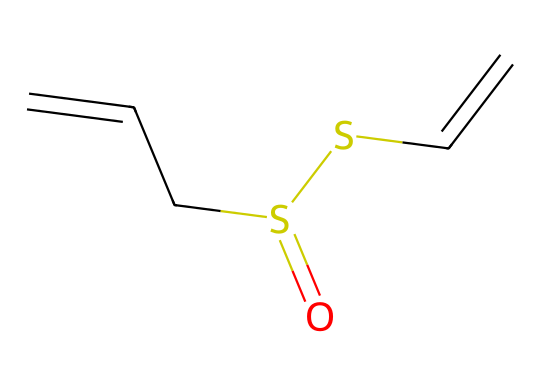How many sulfur atoms are in allicin? By examining the SMILES representation, we see 'S' appears twice, indicating there are two sulfur atoms present.
Answer: two What is the molecular formula for allicin? Based on the SMILES representation, we can count the elements: there are 6 carbon (C), 10 hydrogen (H), and 2 sulfur (S) atoms. Thus, the molecular formula is C6H10S2.
Answer: C6H10S2 What type of functional group does the compound allicin possess? The presence of -S(=O)- indicates that allicin contains a sulfonyl functional group, commonly found in sulfur compounds.
Answer: sulfonyl Which part of the structure indicates it is a sulfur-containing compound? The sulfur atoms ('S') in the SMILES denote that this compound is a sulfur-containing compound, specifically positioned within a thioether structure.
Answer: thioether What is the total number of bonds in the allicin structure? From the SMILES, we can count the double bonds and single bonds: there are 3 double bonds and several single bonds (totaling 8); therefore, there are 11 bonds in total.
Answer: 11 How many carbon-carbon double bonds are present in allicin? The two 'C=C' segments in the SMILES indicate there are two carbon-carbon double bonds in the structure.
Answer: two What type of isomerism can allicin exhibit based on its structure? Allicin can exhibit geometric (cis/trans) isomerism due to the presence of double bonds, which restrict rotation and allow for different spatial arrangements.
Answer: geometric isomerism 